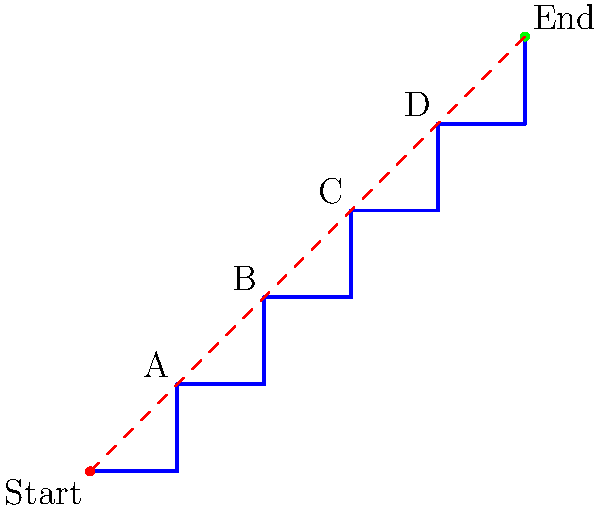In the context of escape route optimization for war-torn areas, analyze the given maze-like structure. Determine the shortest path from Start to End, calculating its length. How does this optimal route compare to the direct linear distance? Express your answer as a ratio of the shortest path length to the direct linear distance, rounded to two decimal places. To solve this problem, we need to follow these steps:

1. Identify the shortest path through the maze:
   The shortest path follows the blue line from (0,0) to (5,5).

2. Calculate the length of the shortest path:
   The path consists of 5 unit squares diagonally, so its length is:
   $$L_{path} = 5\sqrt{2} \approx 7.07$$

3. Calculate the direct linear distance:
   The direct distance is shown by the red dashed line from (0,0) to (5,5).
   Using the distance formula:
   $$L_{direct} = \sqrt{(5-0)^2 + (5-0)^2} = \sqrt{50} = 5\sqrt{2} \approx 7.07$$

4. Calculate the ratio of the shortest path to the direct distance:
   $$\text{Ratio} = \frac{L_{path}}{L_{direct}} = \frac{5\sqrt{2}}{5\sqrt{2}} = 1$$

5. Round the ratio to two decimal places:
   1.00

This result indicates that the optimal escape route through the maze is exactly as long as the direct linear distance, demonstrating an efficient path design despite the complex structure.
Answer: 1.00 